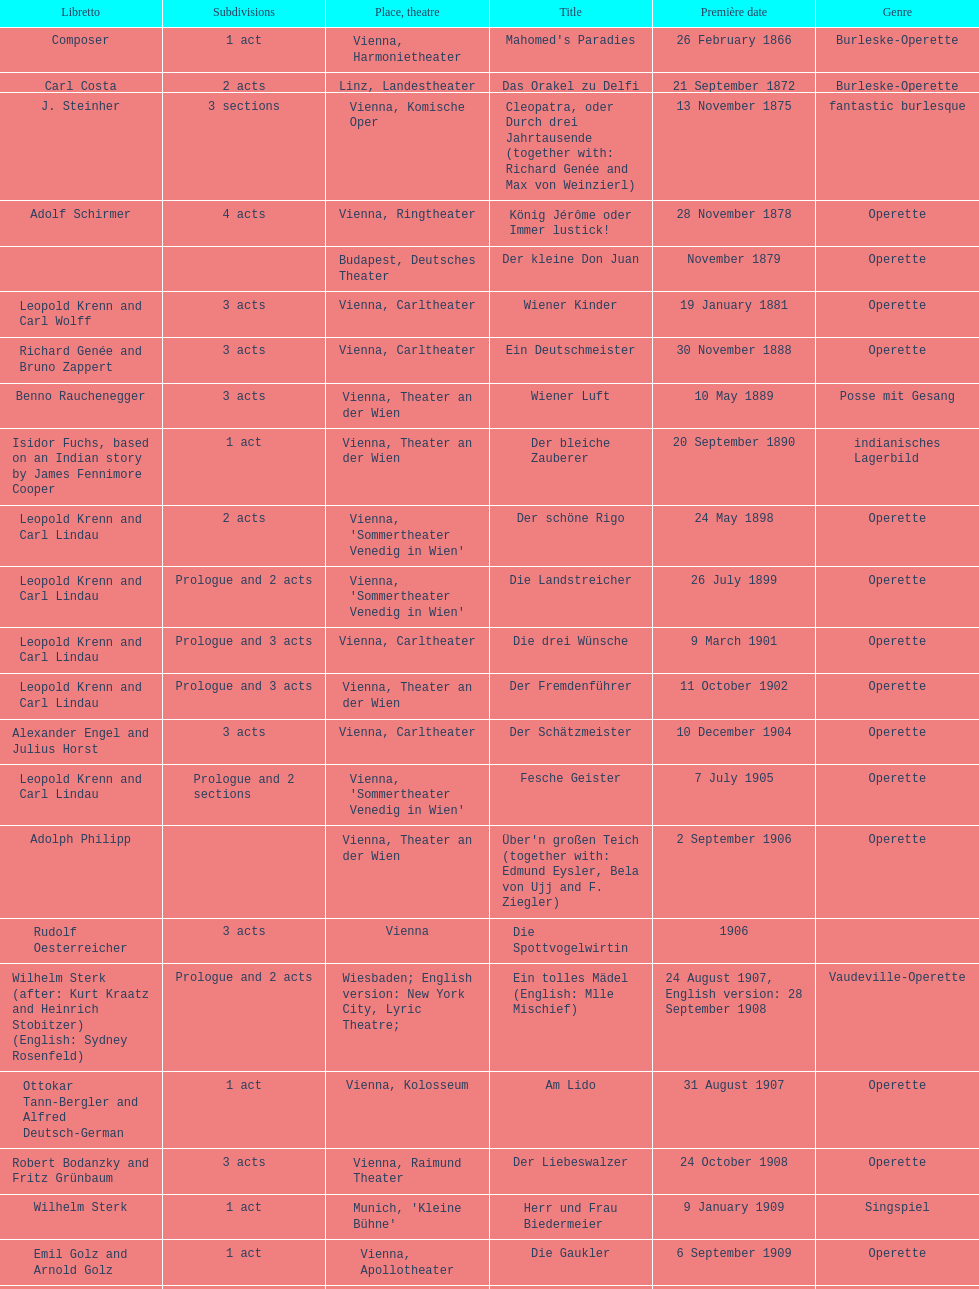How many of his operettas were 3 acts? 13. 